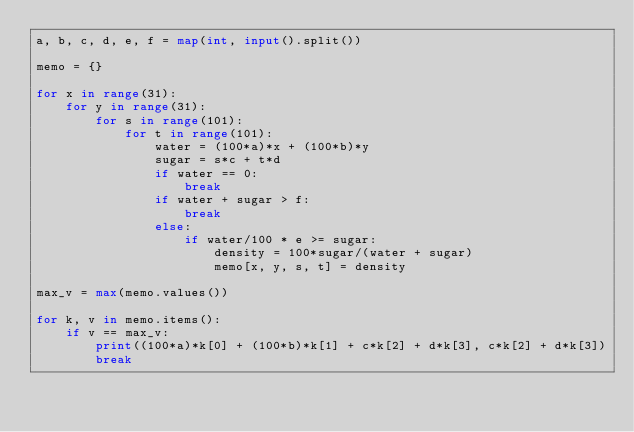<code> <loc_0><loc_0><loc_500><loc_500><_Python_>a, b, c, d, e, f = map(int, input().split())

memo = {}

for x in range(31):
    for y in range(31):
        for s in range(101):
            for t in range(101):
                water = (100*a)*x + (100*b)*y
                sugar = s*c + t*d
                if water == 0:
                    break
                if water + sugar > f:
                    break
                else:
                    if water/100 * e >= sugar:
                        density = 100*sugar/(water + sugar)
                        memo[x, y, s, t] = density

max_v = max(memo.values())

for k, v in memo.items():
    if v == max_v:
        print((100*a)*k[0] + (100*b)*k[1] + c*k[2] + d*k[3], c*k[2] + d*k[3])
        break
</code> 